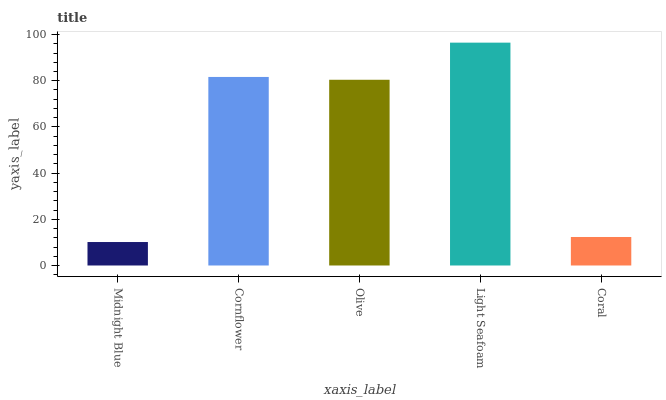Is Midnight Blue the minimum?
Answer yes or no. Yes. Is Light Seafoam the maximum?
Answer yes or no. Yes. Is Cornflower the minimum?
Answer yes or no. No. Is Cornflower the maximum?
Answer yes or no. No. Is Cornflower greater than Midnight Blue?
Answer yes or no. Yes. Is Midnight Blue less than Cornflower?
Answer yes or no. Yes. Is Midnight Blue greater than Cornflower?
Answer yes or no. No. Is Cornflower less than Midnight Blue?
Answer yes or no. No. Is Olive the high median?
Answer yes or no. Yes. Is Olive the low median?
Answer yes or no. Yes. Is Midnight Blue the high median?
Answer yes or no. No. Is Coral the low median?
Answer yes or no. No. 